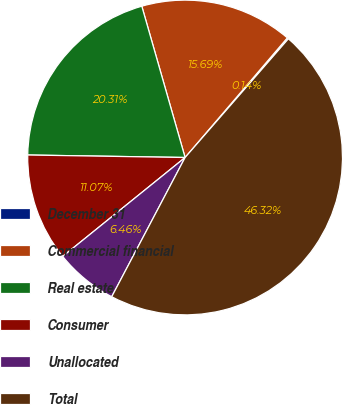Convert chart to OTSL. <chart><loc_0><loc_0><loc_500><loc_500><pie_chart><fcel>December 31<fcel>Commercial financial<fcel>Real estate<fcel>Consumer<fcel>Unallocated<fcel>Total<nl><fcel>0.14%<fcel>15.69%<fcel>20.31%<fcel>11.07%<fcel>6.46%<fcel>46.32%<nl></chart> 